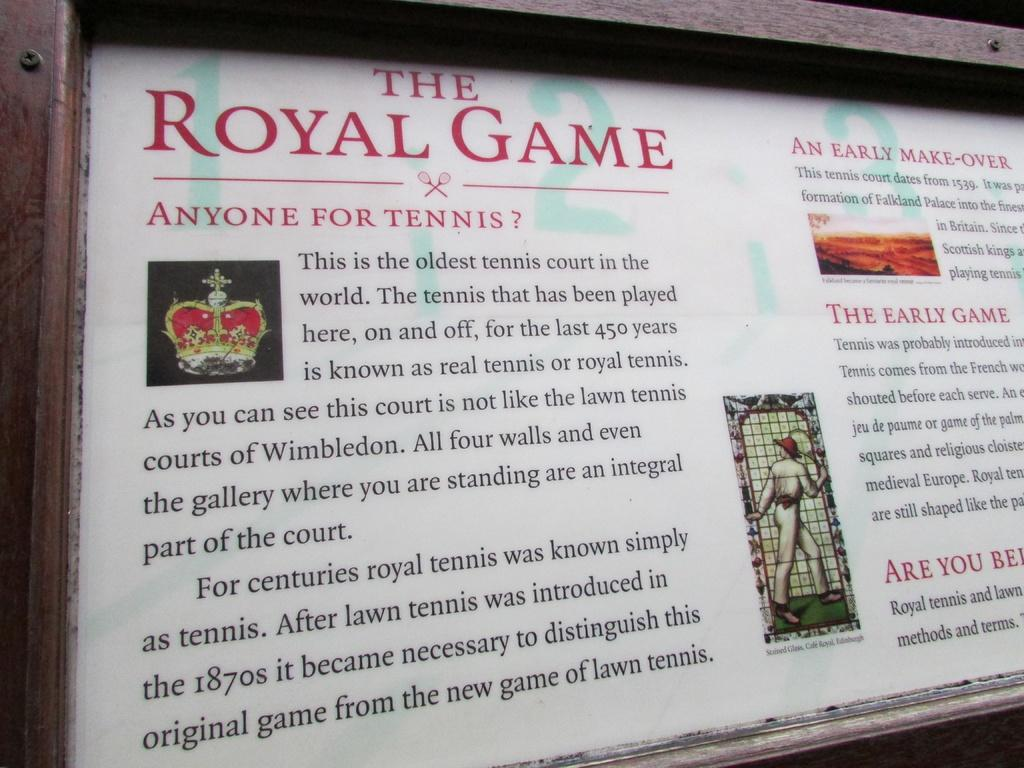<image>
Give a short and clear explanation of the subsequent image. A sign displays the history of The Royal Game 